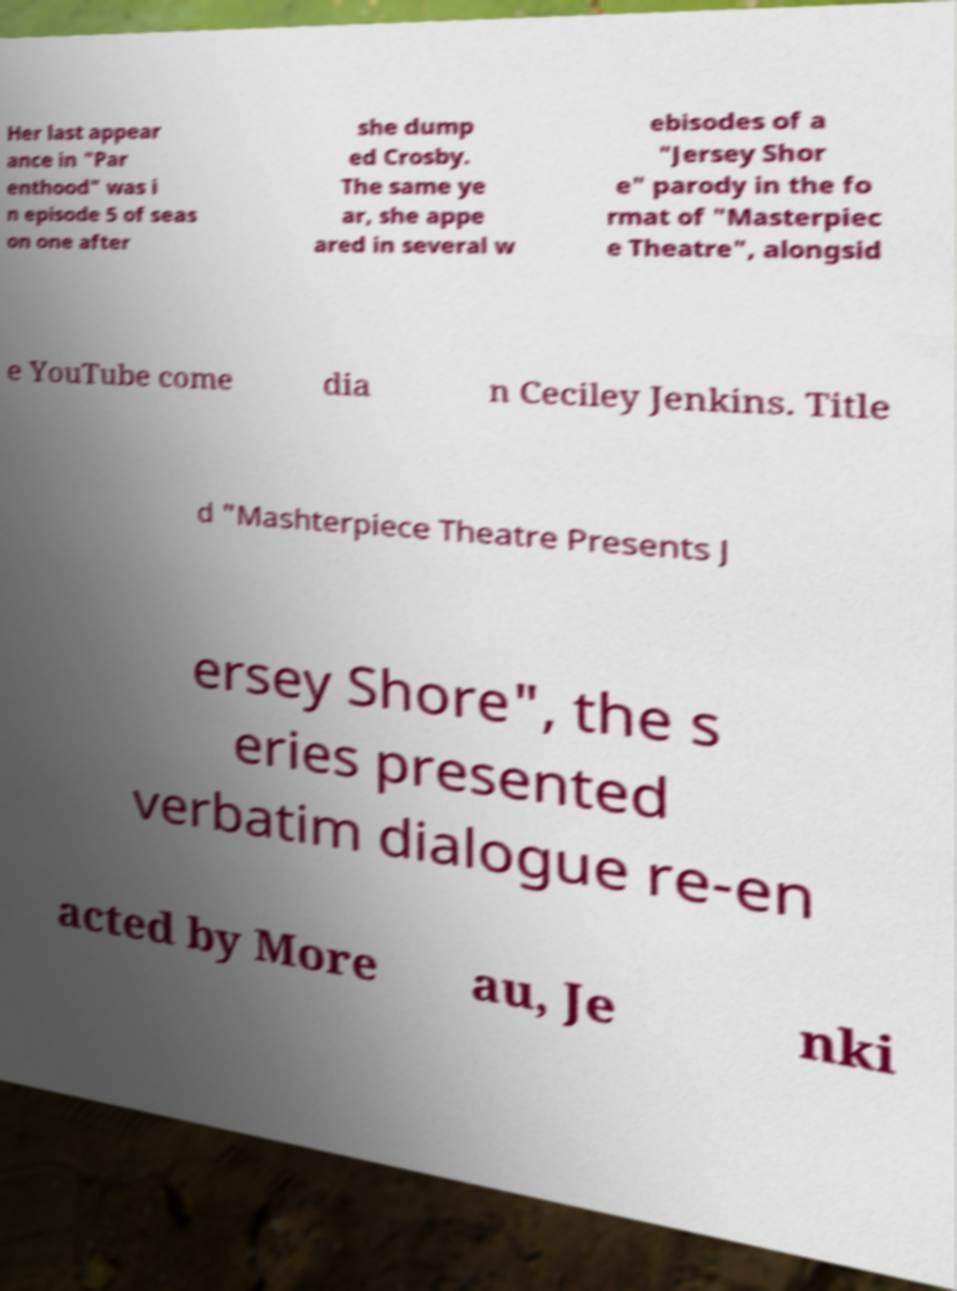For documentation purposes, I need the text within this image transcribed. Could you provide that? Her last appear ance in "Par enthood" was i n episode 5 of seas on one after she dump ed Crosby. The same ye ar, she appe ared in several w ebisodes of a "Jersey Shor e" parody in the fo rmat of "Masterpiec e Theatre", alongsid e YouTube come dia n Ceciley Jenkins. Title d "Mashterpiece Theatre Presents J ersey Shore", the s eries presented verbatim dialogue re-en acted by More au, Je nki 